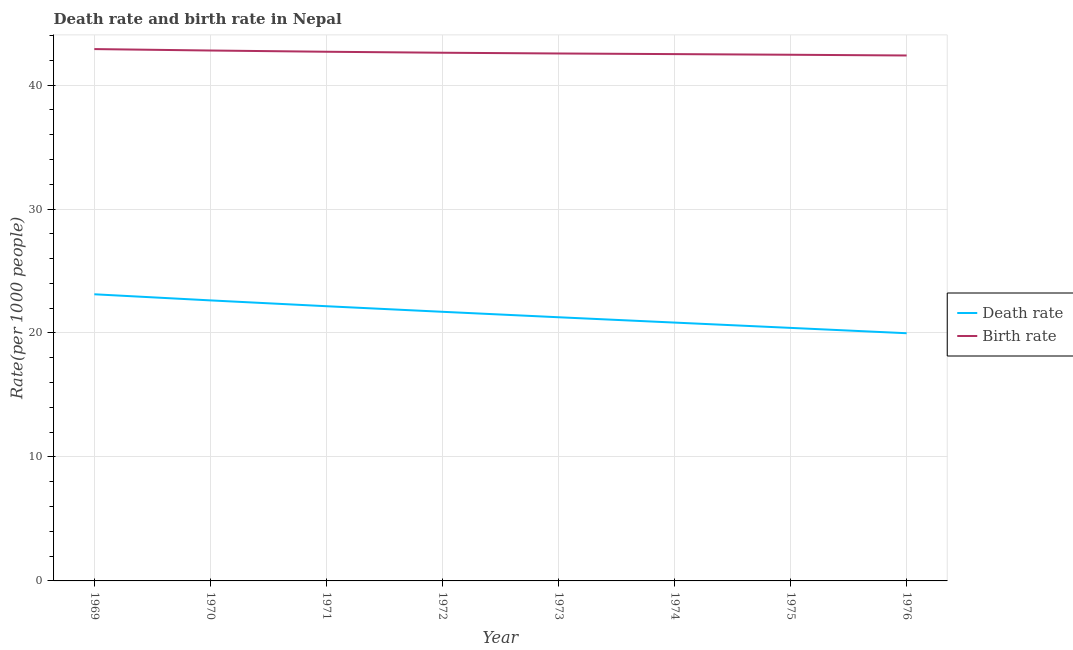How many different coloured lines are there?
Your answer should be very brief. 2. Does the line corresponding to birth rate intersect with the line corresponding to death rate?
Your response must be concise. No. What is the birth rate in 1970?
Offer a very short reply. 42.78. Across all years, what is the maximum birth rate?
Provide a succinct answer. 42.9. Across all years, what is the minimum birth rate?
Your answer should be very brief. 42.38. In which year was the birth rate maximum?
Your answer should be very brief. 1969. In which year was the birth rate minimum?
Provide a succinct answer. 1976. What is the total death rate in the graph?
Make the answer very short. 172.12. What is the difference between the death rate in 1971 and that in 1975?
Offer a terse response. 1.75. What is the difference between the birth rate in 1974 and the death rate in 1975?
Your response must be concise. 22.08. What is the average birth rate per year?
Offer a very short reply. 42.61. In the year 1974, what is the difference between the birth rate and death rate?
Ensure brevity in your answer.  21.66. What is the ratio of the birth rate in 1972 to that in 1973?
Keep it short and to the point. 1. Is the death rate in 1971 less than that in 1976?
Offer a very short reply. No. Is the difference between the death rate in 1975 and 1976 greater than the difference between the birth rate in 1975 and 1976?
Provide a short and direct response. Yes. What is the difference between the highest and the second highest birth rate?
Your answer should be compact. 0.12. What is the difference between the highest and the lowest death rate?
Your answer should be compact. 3.14. In how many years, is the death rate greater than the average death rate taken over all years?
Give a very brief answer. 4. Is the sum of the birth rate in 1970 and 1972 greater than the maximum death rate across all years?
Your answer should be very brief. Yes. Is the birth rate strictly less than the death rate over the years?
Offer a very short reply. No. How many years are there in the graph?
Your answer should be very brief. 8. Are the values on the major ticks of Y-axis written in scientific E-notation?
Offer a terse response. No. Does the graph contain any zero values?
Offer a terse response. No. Where does the legend appear in the graph?
Provide a succinct answer. Center right. What is the title of the graph?
Ensure brevity in your answer.  Death rate and birth rate in Nepal. What is the label or title of the X-axis?
Make the answer very short. Year. What is the label or title of the Y-axis?
Offer a terse response. Rate(per 1000 people). What is the Rate(per 1000 people) of Death rate in 1969?
Keep it short and to the point. 23.12. What is the Rate(per 1000 people) in Birth rate in 1969?
Keep it short and to the point. 42.9. What is the Rate(per 1000 people) of Death rate in 1970?
Offer a terse response. 22.63. What is the Rate(per 1000 people) of Birth rate in 1970?
Ensure brevity in your answer.  42.78. What is the Rate(per 1000 people) of Death rate in 1971?
Offer a very short reply. 22.16. What is the Rate(per 1000 people) in Birth rate in 1971?
Your answer should be compact. 42.69. What is the Rate(per 1000 people) in Death rate in 1972?
Offer a terse response. 21.71. What is the Rate(per 1000 people) in Birth rate in 1972?
Your response must be concise. 42.61. What is the Rate(per 1000 people) of Death rate in 1973?
Keep it short and to the point. 21.27. What is the Rate(per 1000 people) in Birth rate in 1973?
Your answer should be compact. 42.55. What is the Rate(per 1000 people) of Death rate in 1974?
Your answer should be compact. 20.84. What is the Rate(per 1000 people) in Birth rate in 1974?
Your answer should be very brief. 42.49. What is the Rate(per 1000 people) in Death rate in 1975?
Provide a succinct answer. 20.41. What is the Rate(per 1000 people) of Birth rate in 1975?
Your answer should be compact. 42.44. What is the Rate(per 1000 people) of Death rate in 1976?
Provide a short and direct response. 19.98. What is the Rate(per 1000 people) in Birth rate in 1976?
Make the answer very short. 42.38. Across all years, what is the maximum Rate(per 1000 people) of Death rate?
Give a very brief answer. 23.12. Across all years, what is the maximum Rate(per 1000 people) of Birth rate?
Offer a very short reply. 42.9. Across all years, what is the minimum Rate(per 1000 people) of Death rate?
Ensure brevity in your answer.  19.98. Across all years, what is the minimum Rate(per 1000 people) of Birth rate?
Your response must be concise. 42.38. What is the total Rate(per 1000 people) in Death rate in the graph?
Offer a very short reply. 172.12. What is the total Rate(per 1000 people) in Birth rate in the graph?
Your answer should be very brief. 340.84. What is the difference between the Rate(per 1000 people) of Death rate in 1969 and that in 1970?
Provide a succinct answer. 0.49. What is the difference between the Rate(per 1000 people) in Birth rate in 1969 and that in 1970?
Provide a succinct answer. 0.12. What is the difference between the Rate(per 1000 people) of Birth rate in 1969 and that in 1971?
Provide a short and direct response. 0.21. What is the difference between the Rate(per 1000 people) of Death rate in 1969 and that in 1972?
Provide a short and direct response. 1.41. What is the difference between the Rate(per 1000 people) of Birth rate in 1969 and that in 1972?
Your answer should be compact. 0.29. What is the difference between the Rate(per 1000 people) in Death rate in 1969 and that in 1973?
Your answer should be compact. 1.85. What is the difference between the Rate(per 1000 people) in Birth rate in 1969 and that in 1973?
Your answer should be very brief. 0.35. What is the difference between the Rate(per 1000 people) in Death rate in 1969 and that in 1974?
Offer a very short reply. 2.28. What is the difference between the Rate(per 1000 people) in Birth rate in 1969 and that in 1974?
Provide a short and direct response. 0.41. What is the difference between the Rate(per 1000 people) of Death rate in 1969 and that in 1975?
Ensure brevity in your answer.  2.71. What is the difference between the Rate(per 1000 people) of Birth rate in 1969 and that in 1975?
Provide a short and direct response. 0.46. What is the difference between the Rate(per 1000 people) of Death rate in 1969 and that in 1976?
Provide a succinct answer. 3.14. What is the difference between the Rate(per 1000 people) of Birth rate in 1969 and that in 1976?
Your answer should be very brief. 0.52. What is the difference between the Rate(per 1000 people) of Death rate in 1970 and that in 1971?
Make the answer very short. 0.47. What is the difference between the Rate(per 1000 people) of Birth rate in 1970 and that in 1971?
Keep it short and to the point. 0.1. What is the difference between the Rate(per 1000 people) of Death rate in 1970 and that in 1972?
Give a very brief answer. 0.92. What is the difference between the Rate(per 1000 people) of Birth rate in 1970 and that in 1972?
Keep it short and to the point. 0.18. What is the difference between the Rate(per 1000 people) in Death rate in 1970 and that in 1973?
Keep it short and to the point. 1.36. What is the difference between the Rate(per 1000 people) of Birth rate in 1970 and that in 1973?
Provide a short and direct response. 0.24. What is the difference between the Rate(per 1000 people) of Death rate in 1970 and that in 1974?
Your answer should be compact. 1.79. What is the difference between the Rate(per 1000 people) in Birth rate in 1970 and that in 1974?
Ensure brevity in your answer.  0.29. What is the difference between the Rate(per 1000 people) in Death rate in 1970 and that in 1975?
Provide a succinct answer. 2.22. What is the difference between the Rate(per 1000 people) of Birth rate in 1970 and that in 1975?
Give a very brief answer. 0.34. What is the difference between the Rate(per 1000 people) in Death rate in 1970 and that in 1976?
Your answer should be very brief. 2.65. What is the difference between the Rate(per 1000 people) of Birth rate in 1970 and that in 1976?
Your response must be concise. 0.4. What is the difference between the Rate(per 1000 people) in Death rate in 1971 and that in 1972?
Ensure brevity in your answer.  0.45. What is the difference between the Rate(per 1000 people) in Birth rate in 1971 and that in 1972?
Your answer should be compact. 0.08. What is the difference between the Rate(per 1000 people) of Death rate in 1971 and that in 1973?
Provide a short and direct response. 0.89. What is the difference between the Rate(per 1000 people) of Birth rate in 1971 and that in 1973?
Offer a terse response. 0.14. What is the difference between the Rate(per 1000 people) in Death rate in 1971 and that in 1974?
Your answer should be very brief. 1.32. What is the difference between the Rate(per 1000 people) in Birth rate in 1971 and that in 1974?
Provide a succinct answer. 0.19. What is the difference between the Rate(per 1000 people) of Death rate in 1971 and that in 1975?
Keep it short and to the point. 1.75. What is the difference between the Rate(per 1000 people) in Birth rate in 1971 and that in 1975?
Offer a terse response. 0.24. What is the difference between the Rate(per 1000 people) of Death rate in 1971 and that in 1976?
Give a very brief answer. 2.18. What is the difference between the Rate(per 1000 people) of Birth rate in 1971 and that in 1976?
Ensure brevity in your answer.  0.3. What is the difference between the Rate(per 1000 people) in Death rate in 1972 and that in 1973?
Offer a terse response. 0.44. What is the difference between the Rate(per 1000 people) in Birth rate in 1972 and that in 1973?
Offer a very short reply. 0.06. What is the difference between the Rate(per 1000 people) in Death rate in 1972 and that in 1974?
Offer a very short reply. 0.87. What is the difference between the Rate(per 1000 people) of Birth rate in 1972 and that in 1974?
Offer a terse response. 0.11. What is the difference between the Rate(per 1000 people) of Death rate in 1972 and that in 1975?
Give a very brief answer. 1.3. What is the difference between the Rate(per 1000 people) of Birth rate in 1972 and that in 1975?
Offer a very short reply. 0.16. What is the difference between the Rate(per 1000 people) in Death rate in 1972 and that in 1976?
Your answer should be very brief. 1.73. What is the difference between the Rate(per 1000 people) of Birth rate in 1972 and that in 1976?
Offer a very short reply. 0.22. What is the difference between the Rate(per 1000 people) in Death rate in 1973 and that in 1974?
Provide a short and direct response. 0.43. What is the difference between the Rate(per 1000 people) of Birth rate in 1973 and that in 1974?
Your response must be concise. 0.05. What is the difference between the Rate(per 1000 people) of Death rate in 1973 and that in 1975?
Give a very brief answer. 0.86. What is the difference between the Rate(per 1000 people) in Birth rate in 1973 and that in 1975?
Provide a short and direct response. 0.1. What is the difference between the Rate(per 1000 people) of Death rate in 1973 and that in 1976?
Give a very brief answer. 1.29. What is the difference between the Rate(per 1000 people) of Birth rate in 1973 and that in 1976?
Make the answer very short. 0.16. What is the difference between the Rate(per 1000 people) in Death rate in 1974 and that in 1975?
Make the answer very short. 0.43. What is the difference between the Rate(per 1000 people) in Birth rate in 1974 and that in 1975?
Make the answer very short. 0.05. What is the difference between the Rate(per 1000 people) in Death rate in 1974 and that in 1976?
Your answer should be compact. 0.86. What is the difference between the Rate(per 1000 people) of Birth rate in 1974 and that in 1976?
Provide a succinct answer. 0.11. What is the difference between the Rate(per 1000 people) of Death rate in 1975 and that in 1976?
Provide a succinct answer. 0.43. What is the difference between the Rate(per 1000 people) of Death rate in 1969 and the Rate(per 1000 people) of Birth rate in 1970?
Make the answer very short. -19.66. What is the difference between the Rate(per 1000 people) of Death rate in 1969 and the Rate(per 1000 people) of Birth rate in 1971?
Provide a short and direct response. -19.56. What is the difference between the Rate(per 1000 people) in Death rate in 1969 and the Rate(per 1000 people) in Birth rate in 1972?
Offer a very short reply. -19.48. What is the difference between the Rate(per 1000 people) in Death rate in 1969 and the Rate(per 1000 people) in Birth rate in 1973?
Your response must be concise. -19.42. What is the difference between the Rate(per 1000 people) in Death rate in 1969 and the Rate(per 1000 people) in Birth rate in 1974?
Ensure brevity in your answer.  -19.37. What is the difference between the Rate(per 1000 people) of Death rate in 1969 and the Rate(per 1000 people) of Birth rate in 1975?
Make the answer very short. -19.32. What is the difference between the Rate(per 1000 people) of Death rate in 1969 and the Rate(per 1000 people) of Birth rate in 1976?
Your response must be concise. -19.26. What is the difference between the Rate(per 1000 people) in Death rate in 1970 and the Rate(per 1000 people) in Birth rate in 1971?
Provide a succinct answer. -20.06. What is the difference between the Rate(per 1000 people) of Death rate in 1970 and the Rate(per 1000 people) of Birth rate in 1972?
Your response must be concise. -19.98. What is the difference between the Rate(per 1000 people) of Death rate in 1970 and the Rate(per 1000 people) of Birth rate in 1973?
Provide a short and direct response. -19.92. What is the difference between the Rate(per 1000 people) in Death rate in 1970 and the Rate(per 1000 people) in Birth rate in 1974?
Offer a terse response. -19.86. What is the difference between the Rate(per 1000 people) in Death rate in 1970 and the Rate(per 1000 people) in Birth rate in 1975?
Provide a short and direct response. -19.81. What is the difference between the Rate(per 1000 people) of Death rate in 1970 and the Rate(per 1000 people) of Birth rate in 1976?
Your response must be concise. -19.75. What is the difference between the Rate(per 1000 people) in Death rate in 1971 and the Rate(per 1000 people) in Birth rate in 1972?
Your response must be concise. -20.45. What is the difference between the Rate(per 1000 people) in Death rate in 1971 and the Rate(per 1000 people) in Birth rate in 1973?
Provide a succinct answer. -20.39. What is the difference between the Rate(per 1000 people) of Death rate in 1971 and the Rate(per 1000 people) of Birth rate in 1974?
Ensure brevity in your answer.  -20.34. What is the difference between the Rate(per 1000 people) in Death rate in 1971 and the Rate(per 1000 people) in Birth rate in 1975?
Offer a terse response. -20.28. What is the difference between the Rate(per 1000 people) of Death rate in 1971 and the Rate(per 1000 people) of Birth rate in 1976?
Your response must be concise. -20.22. What is the difference between the Rate(per 1000 people) in Death rate in 1972 and the Rate(per 1000 people) in Birth rate in 1973?
Offer a terse response. -20.84. What is the difference between the Rate(per 1000 people) in Death rate in 1972 and the Rate(per 1000 people) in Birth rate in 1974?
Keep it short and to the point. -20.79. What is the difference between the Rate(per 1000 people) in Death rate in 1972 and the Rate(per 1000 people) in Birth rate in 1975?
Your answer should be very brief. -20.73. What is the difference between the Rate(per 1000 people) in Death rate in 1972 and the Rate(per 1000 people) in Birth rate in 1976?
Keep it short and to the point. -20.68. What is the difference between the Rate(per 1000 people) of Death rate in 1973 and the Rate(per 1000 people) of Birth rate in 1974?
Your response must be concise. -21.23. What is the difference between the Rate(per 1000 people) of Death rate in 1973 and the Rate(per 1000 people) of Birth rate in 1975?
Your answer should be compact. -21.17. What is the difference between the Rate(per 1000 people) in Death rate in 1973 and the Rate(per 1000 people) in Birth rate in 1976?
Keep it short and to the point. -21.11. What is the difference between the Rate(per 1000 people) of Death rate in 1974 and the Rate(per 1000 people) of Birth rate in 1975?
Offer a terse response. -21.6. What is the difference between the Rate(per 1000 people) of Death rate in 1974 and the Rate(per 1000 people) of Birth rate in 1976?
Offer a very short reply. -21.54. What is the difference between the Rate(per 1000 people) in Death rate in 1975 and the Rate(per 1000 people) in Birth rate in 1976?
Your answer should be compact. -21.97. What is the average Rate(per 1000 people) in Death rate per year?
Your answer should be compact. 21.51. What is the average Rate(per 1000 people) of Birth rate per year?
Provide a succinct answer. 42.6. In the year 1969, what is the difference between the Rate(per 1000 people) of Death rate and Rate(per 1000 people) of Birth rate?
Ensure brevity in your answer.  -19.78. In the year 1970, what is the difference between the Rate(per 1000 people) of Death rate and Rate(per 1000 people) of Birth rate?
Offer a terse response. -20.16. In the year 1971, what is the difference between the Rate(per 1000 people) of Death rate and Rate(per 1000 people) of Birth rate?
Provide a short and direct response. -20.53. In the year 1972, what is the difference between the Rate(per 1000 people) of Death rate and Rate(per 1000 people) of Birth rate?
Give a very brief answer. -20.9. In the year 1973, what is the difference between the Rate(per 1000 people) of Death rate and Rate(per 1000 people) of Birth rate?
Give a very brief answer. -21.28. In the year 1974, what is the difference between the Rate(per 1000 people) of Death rate and Rate(per 1000 people) of Birth rate?
Provide a short and direct response. -21.66. In the year 1975, what is the difference between the Rate(per 1000 people) of Death rate and Rate(per 1000 people) of Birth rate?
Give a very brief answer. -22.03. In the year 1976, what is the difference between the Rate(per 1000 people) in Death rate and Rate(per 1000 people) in Birth rate?
Ensure brevity in your answer.  -22.4. What is the ratio of the Rate(per 1000 people) of Death rate in 1969 to that in 1970?
Offer a very short reply. 1.02. What is the ratio of the Rate(per 1000 people) in Birth rate in 1969 to that in 1970?
Keep it short and to the point. 1. What is the ratio of the Rate(per 1000 people) of Death rate in 1969 to that in 1971?
Provide a short and direct response. 1.04. What is the ratio of the Rate(per 1000 people) of Birth rate in 1969 to that in 1971?
Provide a short and direct response. 1. What is the ratio of the Rate(per 1000 people) in Death rate in 1969 to that in 1972?
Your response must be concise. 1.07. What is the ratio of the Rate(per 1000 people) of Death rate in 1969 to that in 1973?
Give a very brief answer. 1.09. What is the ratio of the Rate(per 1000 people) in Birth rate in 1969 to that in 1973?
Give a very brief answer. 1.01. What is the ratio of the Rate(per 1000 people) in Death rate in 1969 to that in 1974?
Your response must be concise. 1.11. What is the ratio of the Rate(per 1000 people) of Birth rate in 1969 to that in 1974?
Keep it short and to the point. 1.01. What is the ratio of the Rate(per 1000 people) in Death rate in 1969 to that in 1975?
Keep it short and to the point. 1.13. What is the ratio of the Rate(per 1000 people) in Birth rate in 1969 to that in 1975?
Provide a short and direct response. 1.01. What is the ratio of the Rate(per 1000 people) of Death rate in 1969 to that in 1976?
Your response must be concise. 1.16. What is the ratio of the Rate(per 1000 people) of Birth rate in 1969 to that in 1976?
Ensure brevity in your answer.  1.01. What is the ratio of the Rate(per 1000 people) in Death rate in 1970 to that in 1971?
Ensure brevity in your answer.  1.02. What is the ratio of the Rate(per 1000 people) of Birth rate in 1970 to that in 1971?
Make the answer very short. 1. What is the ratio of the Rate(per 1000 people) in Death rate in 1970 to that in 1972?
Offer a terse response. 1.04. What is the ratio of the Rate(per 1000 people) in Birth rate in 1970 to that in 1972?
Ensure brevity in your answer.  1. What is the ratio of the Rate(per 1000 people) of Death rate in 1970 to that in 1973?
Ensure brevity in your answer.  1.06. What is the ratio of the Rate(per 1000 people) of Birth rate in 1970 to that in 1973?
Give a very brief answer. 1.01. What is the ratio of the Rate(per 1000 people) in Death rate in 1970 to that in 1974?
Make the answer very short. 1.09. What is the ratio of the Rate(per 1000 people) in Birth rate in 1970 to that in 1974?
Offer a terse response. 1.01. What is the ratio of the Rate(per 1000 people) in Death rate in 1970 to that in 1975?
Offer a very short reply. 1.11. What is the ratio of the Rate(per 1000 people) in Birth rate in 1970 to that in 1975?
Provide a succinct answer. 1.01. What is the ratio of the Rate(per 1000 people) of Death rate in 1970 to that in 1976?
Your answer should be very brief. 1.13. What is the ratio of the Rate(per 1000 people) in Birth rate in 1970 to that in 1976?
Provide a short and direct response. 1.01. What is the ratio of the Rate(per 1000 people) of Death rate in 1971 to that in 1972?
Provide a succinct answer. 1.02. What is the ratio of the Rate(per 1000 people) in Birth rate in 1971 to that in 1972?
Offer a terse response. 1. What is the ratio of the Rate(per 1000 people) of Death rate in 1971 to that in 1973?
Keep it short and to the point. 1.04. What is the ratio of the Rate(per 1000 people) in Death rate in 1971 to that in 1974?
Make the answer very short. 1.06. What is the ratio of the Rate(per 1000 people) of Death rate in 1971 to that in 1975?
Provide a short and direct response. 1.09. What is the ratio of the Rate(per 1000 people) in Birth rate in 1971 to that in 1975?
Make the answer very short. 1.01. What is the ratio of the Rate(per 1000 people) in Death rate in 1971 to that in 1976?
Your answer should be very brief. 1.11. What is the ratio of the Rate(per 1000 people) in Birth rate in 1971 to that in 1976?
Keep it short and to the point. 1.01. What is the ratio of the Rate(per 1000 people) in Death rate in 1972 to that in 1973?
Ensure brevity in your answer.  1.02. What is the ratio of the Rate(per 1000 people) in Birth rate in 1972 to that in 1973?
Your answer should be compact. 1. What is the ratio of the Rate(per 1000 people) of Death rate in 1972 to that in 1974?
Your answer should be compact. 1.04. What is the ratio of the Rate(per 1000 people) in Birth rate in 1972 to that in 1974?
Give a very brief answer. 1. What is the ratio of the Rate(per 1000 people) in Death rate in 1972 to that in 1975?
Provide a short and direct response. 1.06. What is the ratio of the Rate(per 1000 people) in Birth rate in 1972 to that in 1975?
Your answer should be compact. 1. What is the ratio of the Rate(per 1000 people) in Death rate in 1972 to that in 1976?
Offer a very short reply. 1.09. What is the ratio of the Rate(per 1000 people) in Death rate in 1973 to that in 1974?
Offer a terse response. 1.02. What is the ratio of the Rate(per 1000 people) of Birth rate in 1973 to that in 1974?
Provide a succinct answer. 1. What is the ratio of the Rate(per 1000 people) of Death rate in 1973 to that in 1975?
Provide a short and direct response. 1.04. What is the ratio of the Rate(per 1000 people) of Birth rate in 1973 to that in 1975?
Make the answer very short. 1. What is the ratio of the Rate(per 1000 people) in Death rate in 1973 to that in 1976?
Keep it short and to the point. 1.06. What is the ratio of the Rate(per 1000 people) of Birth rate in 1973 to that in 1976?
Your answer should be compact. 1. What is the ratio of the Rate(per 1000 people) in Death rate in 1974 to that in 1975?
Offer a very short reply. 1.02. What is the ratio of the Rate(per 1000 people) in Birth rate in 1974 to that in 1975?
Provide a short and direct response. 1. What is the ratio of the Rate(per 1000 people) of Death rate in 1974 to that in 1976?
Keep it short and to the point. 1.04. What is the ratio of the Rate(per 1000 people) of Birth rate in 1974 to that in 1976?
Your answer should be compact. 1. What is the ratio of the Rate(per 1000 people) in Death rate in 1975 to that in 1976?
Provide a short and direct response. 1.02. What is the difference between the highest and the second highest Rate(per 1000 people) of Death rate?
Keep it short and to the point. 0.49. What is the difference between the highest and the second highest Rate(per 1000 people) in Birth rate?
Your response must be concise. 0.12. What is the difference between the highest and the lowest Rate(per 1000 people) in Death rate?
Your answer should be very brief. 3.14. What is the difference between the highest and the lowest Rate(per 1000 people) of Birth rate?
Make the answer very short. 0.52. 